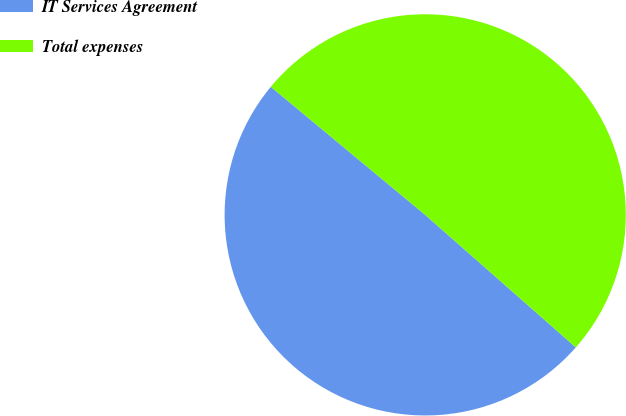Convert chart to OTSL. <chart><loc_0><loc_0><loc_500><loc_500><pie_chart><fcel>IT Services Agreement<fcel>Total expenses<nl><fcel>49.54%<fcel>50.46%<nl></chart> 